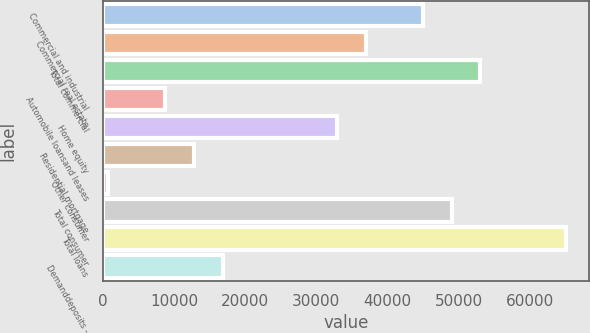Convert chart. <chart><loc_0><loc_0><loc_500><loc_500><bar_chart><fcel>Commercial and industrial<fcel>Commercial real estate<fcel>Total commercial<fcel>Automobile loansand leases<fcel>Home equity<fcel>Residential mortgage<fcel>Other consumer<fcel>Total consumer<fcel>Total loans<fcel>Demanddeposits -<nl><fcel>44986.9<fcel>36933.1<fcel>53040.7<fcel>8744.8<fcel>32906.2<fcel>12771.7<fcel>691<fcel>49013.8<fcel>65121.4<fcel>16798.6<nl></chart> 